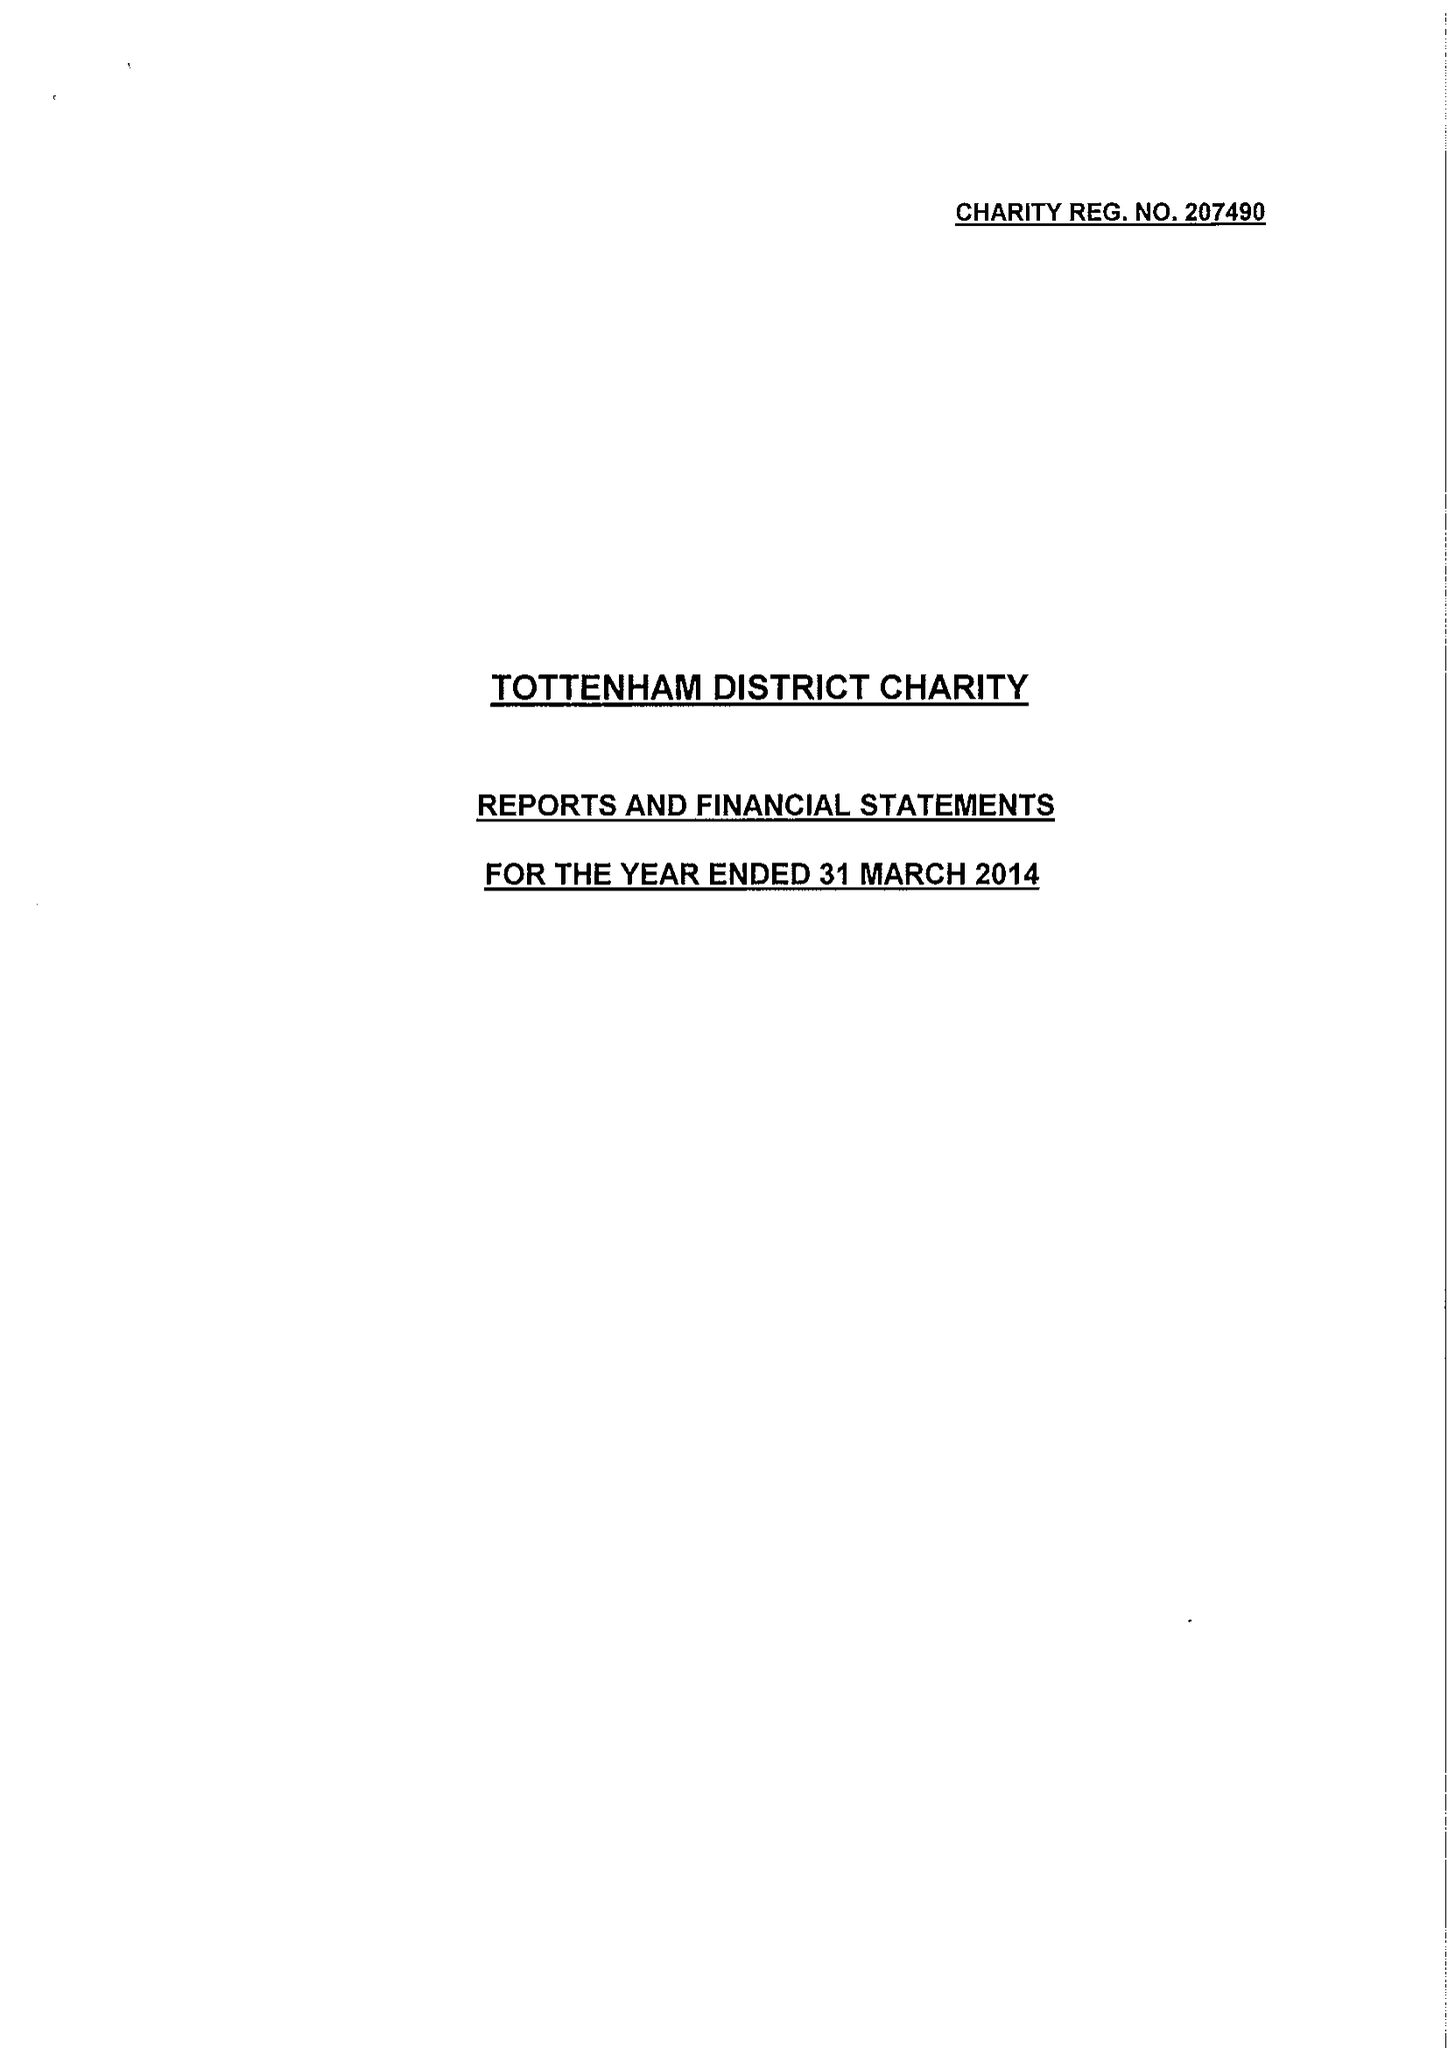What is the value for the address__post_town?
Answer the question using a single word or phrase. LONDON 